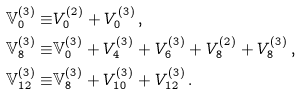<formula> <loc_0><loc_0><loc_500><loc_500>\mathbb { V } ^ { ( 3 ) } _ { 0 } \equiv & V ^ { ( 2 ) } _ { 0 } + V ^ { ( 3 ) } _ { 0 } \, , \\ \mathbb { V } ^ { ( 3 ) } _ { 8 } \equiv & \mathbb { V } ^ { ( 3 ) } _ { 0 } + V ^ { ( 3 ) } _ { 4 } + V ^ { ( 3 ) } _ { 6 } + V ^ { ( 2 ) } _ { 8 } + V ^ { ( 3 ) } _ { 8 } \, , \\ \mathbb { V } ^ { ( 3 ) } _ { 1 2 } \equiv & \mathbb { V } ^ { ( 3 ) } _ { 8 } + V ^ { ( 3 ) } _ { 1 0 } + V ^ { ( 3 ) } _ { 1 2 } \, . \\</formula> 